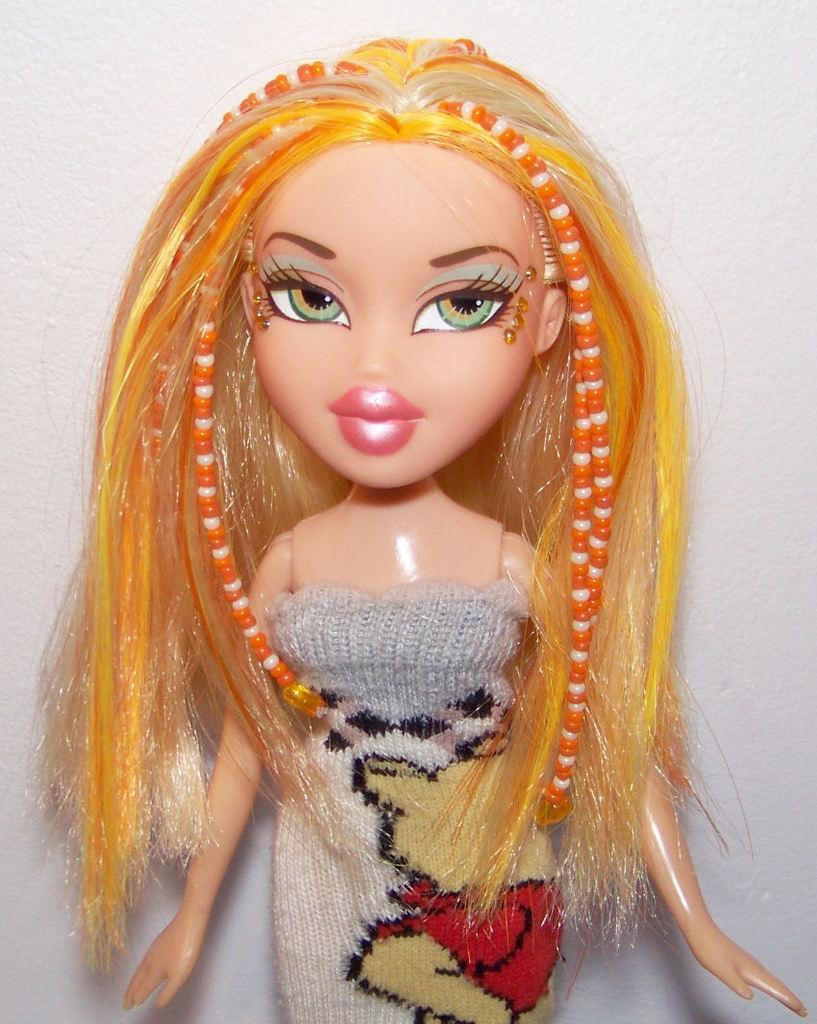Describe this image in one or two sentences. In the center of the image we can see a doll. In the background there is a wall. 